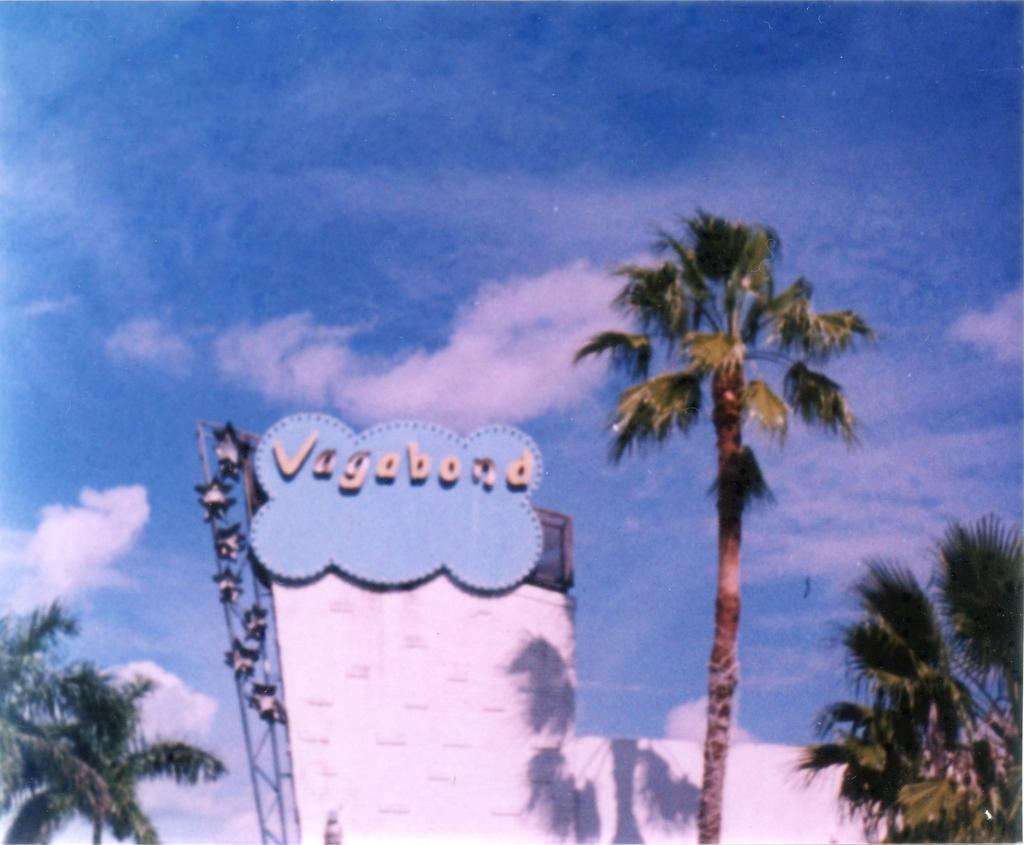Can you describe this image briefly? In this image there is a wall in the middle. At the top of the wall there is some text. In the background there are trees. At the top there is the sky. On the right side there is a palm tree. 